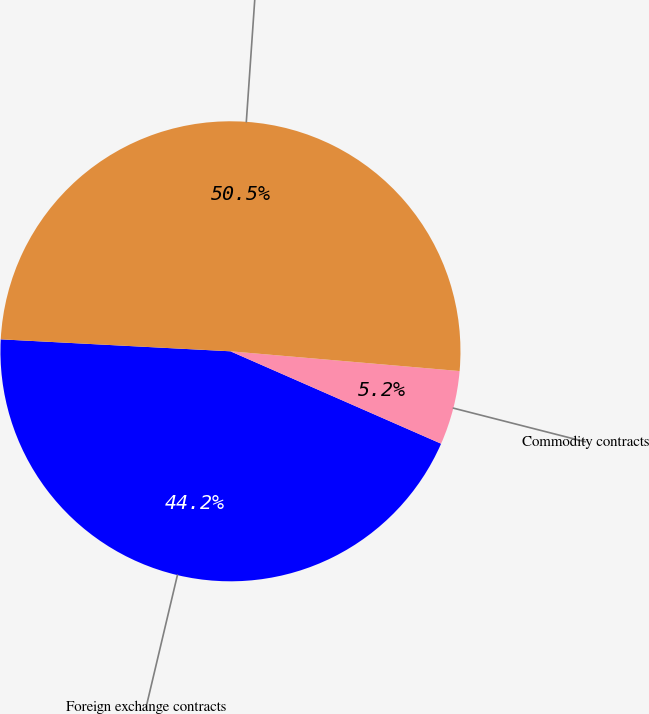Convert chart. <chart><loc_0><loc_0><loc_500><loc_500><pie_chart><fcel>Foreign exchange contracts<fcel>Commodity contracts<fcel>Total derivatives<nl><fcel>44.25%<fcel>5.21%<fcel>50.54%<nl></chart> 